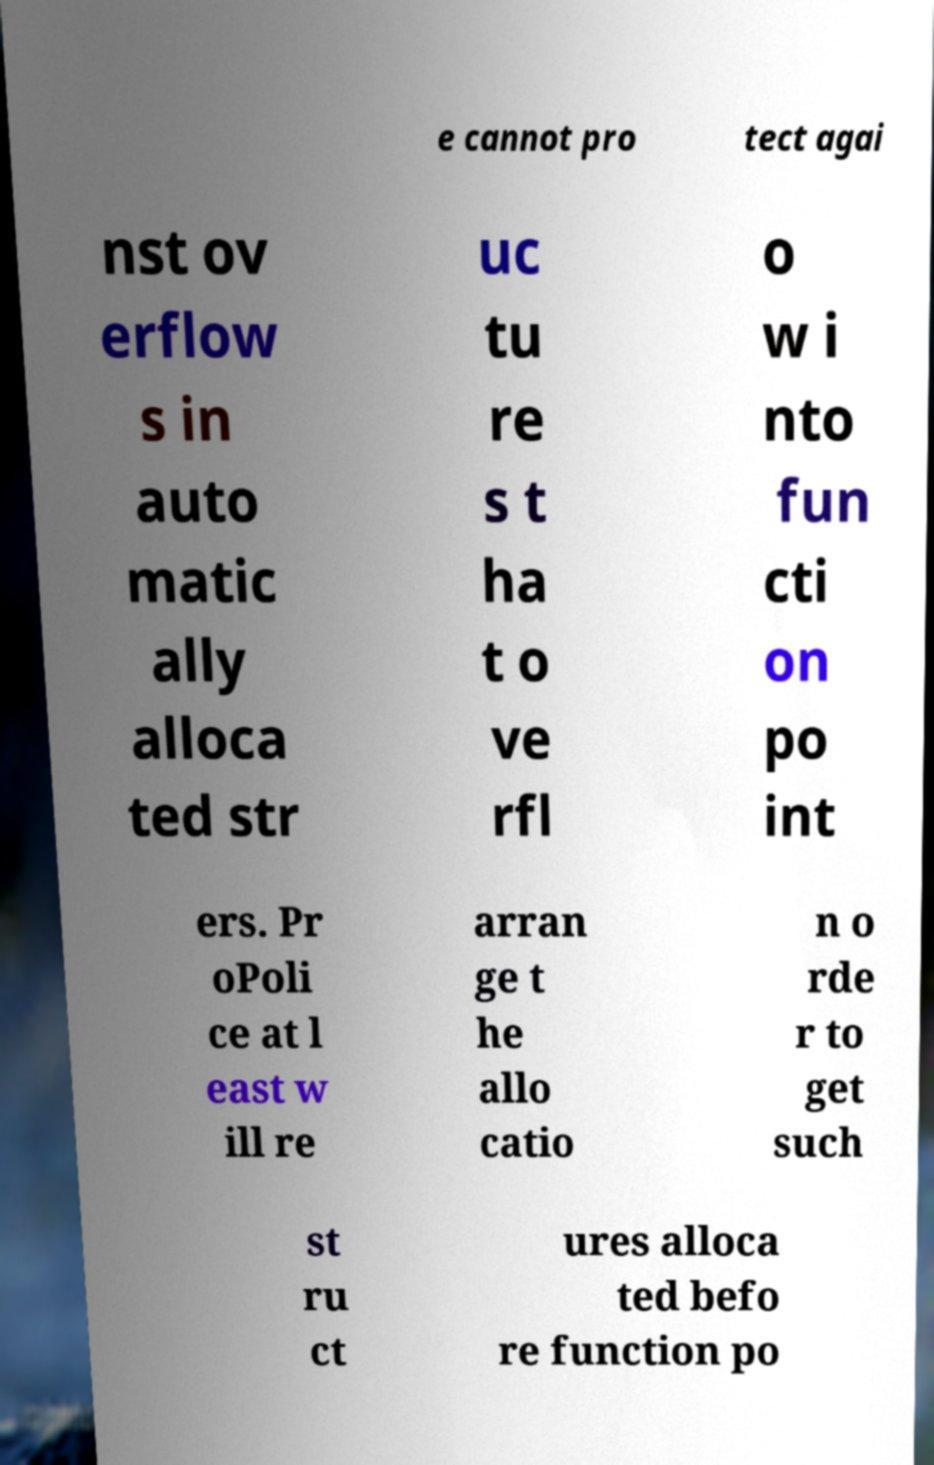For documentation purposes, I need the text within this image transcribed. Could you provide that? e cannot pro tect agai nst ov erflow s in auto matic ally alloca ted str uc tu re s t ha t o ve rfl o w i nto fun cti on po int ers. Pr oPoli ce at l east w ill re arran ge t he allo catio n o rde r to get such st ru ct ures alloca ted befo re function po 